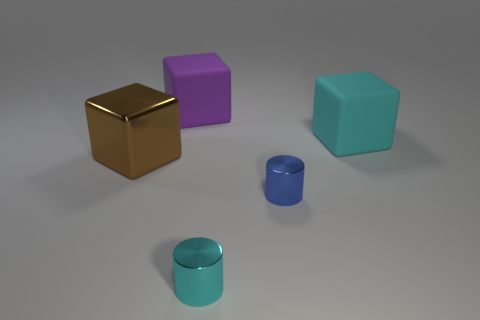There is a large object that is right of the cyan shiny object; what shape is it? The large object to the right of the cyan object is a cube. Its edges are equal in length, and it has a distinctive square shape on each of its visible sides, indicative of a cube's six-sided geometry. 